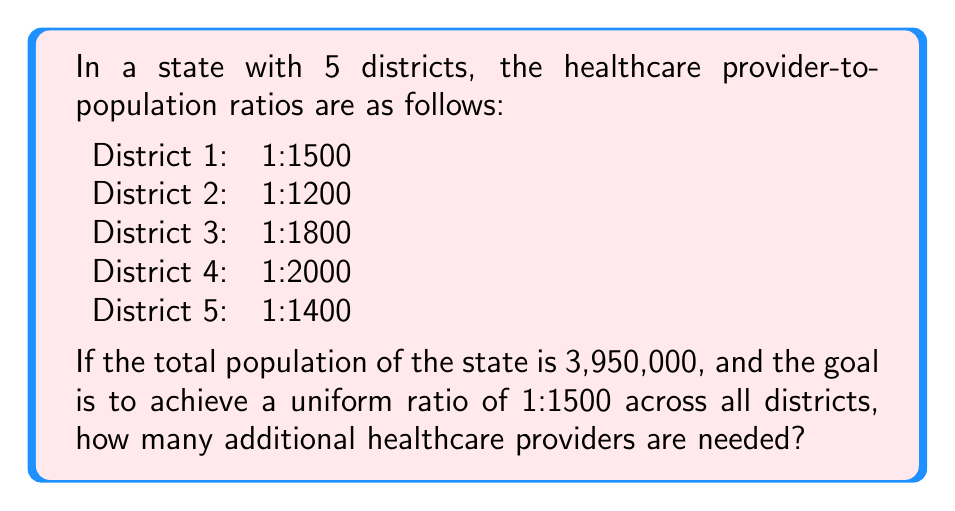Can you answer this question? 1. Calculate the total number of healthcare providers currently:
   $$\frac{3,950,000}{1500} + \frac{3,950,000}{1200} + \frac{3,950,000}{1800} + \frac{3,950,000}{2000} + \frac{3,950,000}{1400} = 2633.33 + 3291.67 + 2194.44 + 1975 + 2821.43 = 12,915.87$$

2. Round down to get the current number of providers: 12,915

3. Calculate the ideal number of providers for a 1:1500 ratio:
   $$\frac{3,950,000}{1500} = 2,633.33$$

4. Round up to get the ideal number of providers: 2,634

5. Calculate the difference:
   $$2,634 - 12,915 = -10,281$$

The negative result indicates we need to reduce the number of providers. However, since the question asks for additional providers needed, we consider this as 0.
Answer: 0 